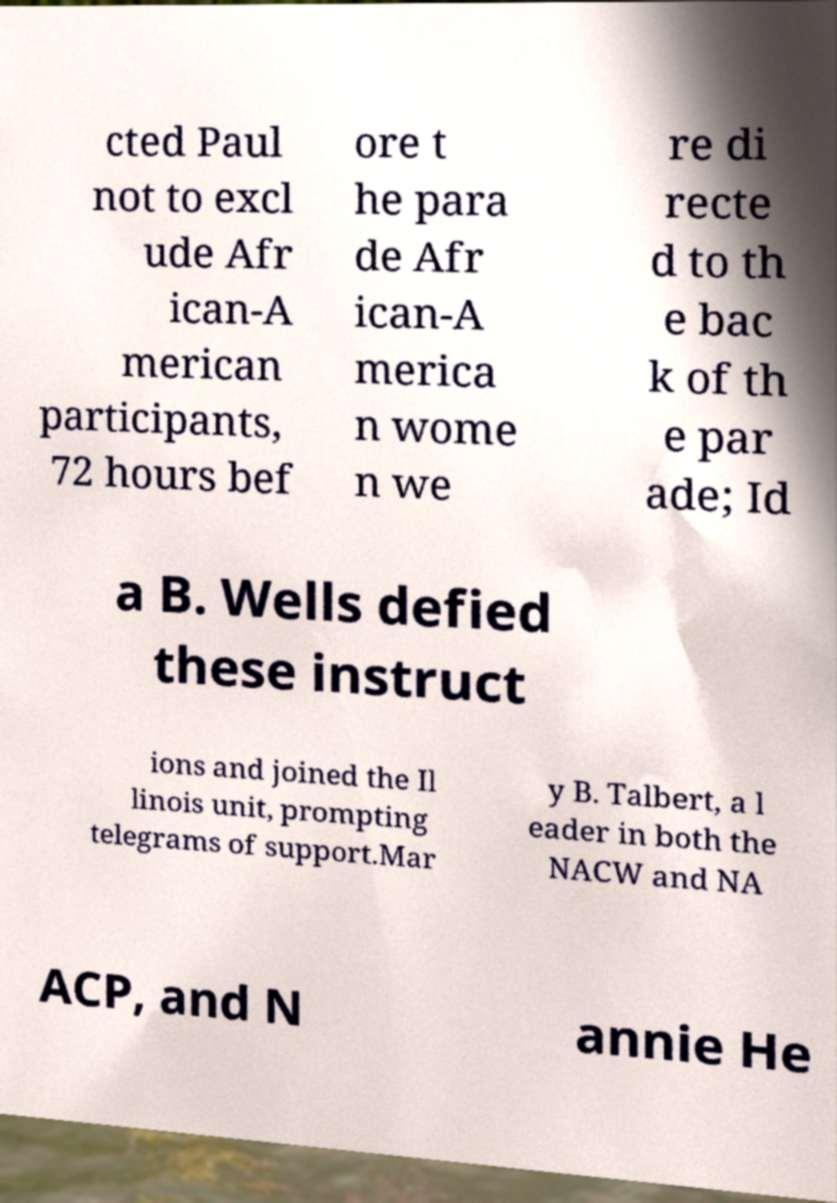Can you accurately transcribe the text from the provided image for me? cted Paul not to excl ude Afr ican-A merican participants, 72 hours bef ore t he para de Afr ican-A merica n wome n we re di recte d to th e bac k of th e par ade; Id a B. Wells defied these instruct ions and joined the Il linois unit, prompting telegrams of support.Mar y B. Talbert, a l eader in both the NACW and NA ACP, and N annie He 